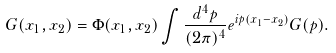<formula> <loc_0><loc_0><loc_500><loc_500>G ( x _ { 1 } , x _ { 2 } ) = \Phi ( x _ { 1 } , x _ { 2 } ) \int \frac { d ^ { 4 } p } { ( 2 \pi ) ^ { 4 } } e ^ { i p ( x _ { 1 } - x _ { 2 } ) } G ( p ) .</formula> 